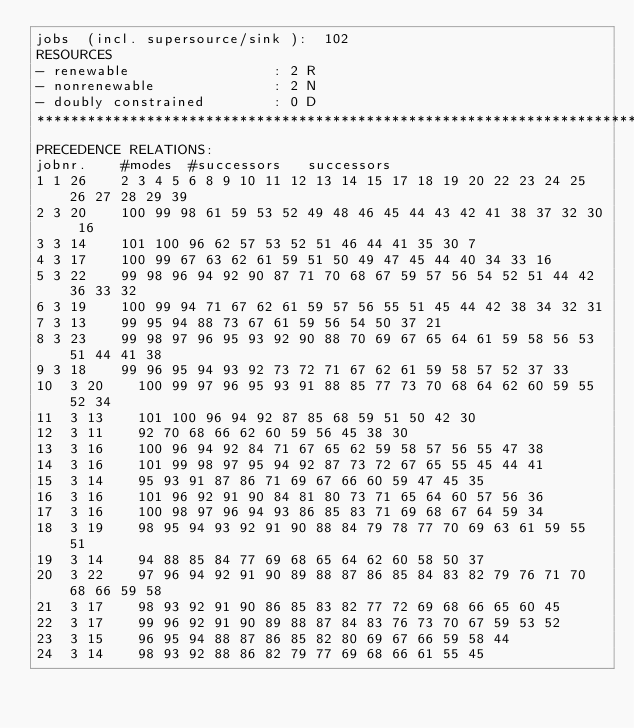Convert code to text. <code><loc_0><loc_0><loc_500><loc_500><_ObjectiveC_>jobs  (incl. supersource/sink ):	102
RESOURCES
- renewable                 : 2 R
- nonrenewable              : 2 N
- doubly constrained        : 0 D
************************************************************************
PRECEDENCE RELATIONS:
jobnr.    #modes  #successors   successors
1	1	26		2 3 4 5 6 8 9 10 11 12 13 14 15 17 18 19 20 22 23 24 25 26 27 28 29 39 
2	3	20		100 99 98 61 59 53 52 49 48 46 45 44 43 42 41 38 37 32 30 16 
3	3	14		101 100 96 62 57 53 52 51 46 44 41 35 30 7 
4	3	17		100 99 67 63 62 61 59 51 50 49 47 45 44 40 34 33 16 
5	3	22		99 98 96 94 92 90 87 71 70 68 67 59 57 56 54 52 51 44 42 36 33 32 
6	3	19		100 99 94 71 67 62 61 59 57 56 55 51 45 44 42 38 34 32 31 
7	3	13		99 95 94 88 73 67 61 59 56 54 50 37 21 
8	3	23		99 98 97 96 95 93 92 90 88 70 69 67 65 64 61 59 58 56 53 51 44 41 38 
9	3	18		99 96 95 94 93 92 73 72 71 67 62 61 59 58 57 52 37 33 
10	3	20		100 99 97 96 95 93 91 88 85 77 73 70 68 64 62 60 59 55 52 34 
11	3	13		101 100 96 94 92 87 85 68 59 51 50 42 30 
12	3	11		92 70 68 66 62 60 59 56 45 38 30 
13	3	16		100 96 94 92 84 71 67 65 62 59 58 57 56 55 47 38 
14	3	16		101 99 98 97 95 94 92 87 73 72 67 65 55 45 44 41 
15	3	14		95 93 91 87 86 71 69 67 66 60 59 47 45 35 
16	3	16		101 96 92 91 90 84 81 80 73 71 65 64 60 57 56 36 
17	3	16		100 98 97 96 94 93 86 85 83 71 69 68 67 64 59 34 
18	3	19		98 95 94 93 92 91 90 88 84 79 78 77 70 69 63 61 59 55 51 
19	3	14		94 88 85 84 77 69 68 65 64 62 60 58 50 37 
20	3	22		97 96 94 92 91 90 89 88 87 86 85 84 83 82 79 76 71 70 68 66 59 58 
21	3	17		98 93 92 91 90 86 85 83 82 77 72 69 68 66 65 60 45 
22	3	17		99 96 92 91 90 89 88 87 84 83 76 73 70 67 59 53 52 
23	3	15		96 95 94 88 87 86 85 82 80 69 67 66 59 58 44 
24	3	14		98 93 92 88 86 82 79 77 69 68 66 61 55 45 </code> 